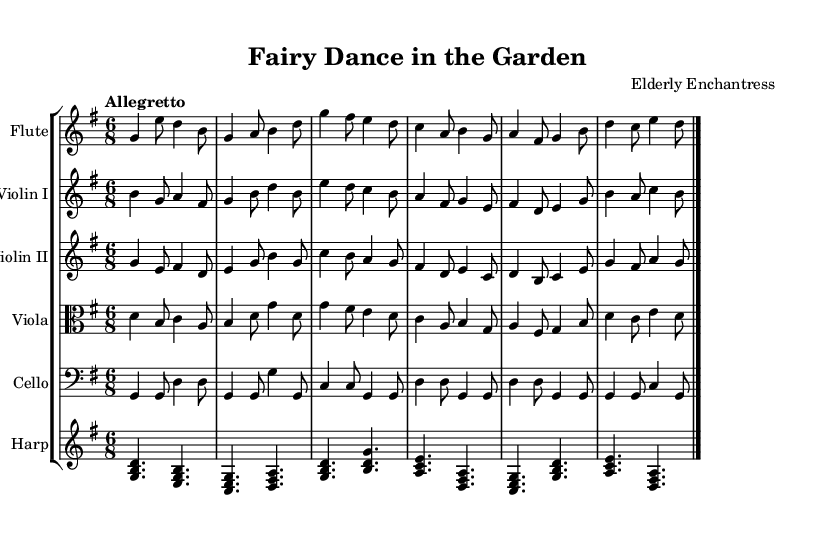What is the key signature of this music? The key signature is G major, indicated by the one sharp (F sharp) shown after the clef at the beginning of each staff.
Answer: G major What is the time signature of this music? The time signature is 6/8, represented by the fraction shown after the clef and before the notes. This indicates that there are six eighth-note beats in each measure.
Answer: 6/8 What is the tempo marking for this piece? The tempo marking is "Allegretto," which is indicated at the beginning, suggesting a moderately fast tempo.
Answer: Allegretto How many instruments are featured in this concerto? The sheet music displays a total of six different instruments: flute, violin I, violin II, viola, cello, and harp, as indicated by the different staves in the score.
Answer: Six What is the primary theme of this piece? The title "Fairy Dance in the Garden" suggests that the music captures a whimsical and magical theme, celebrating the essence of nature and fairies.
Answer: Whimsical Which instruments play the first melodic line? The flute is featured as the first instrument with the melodic line, starting the piece with its part clearly indicated at the top of the score.
Answer: Flute 